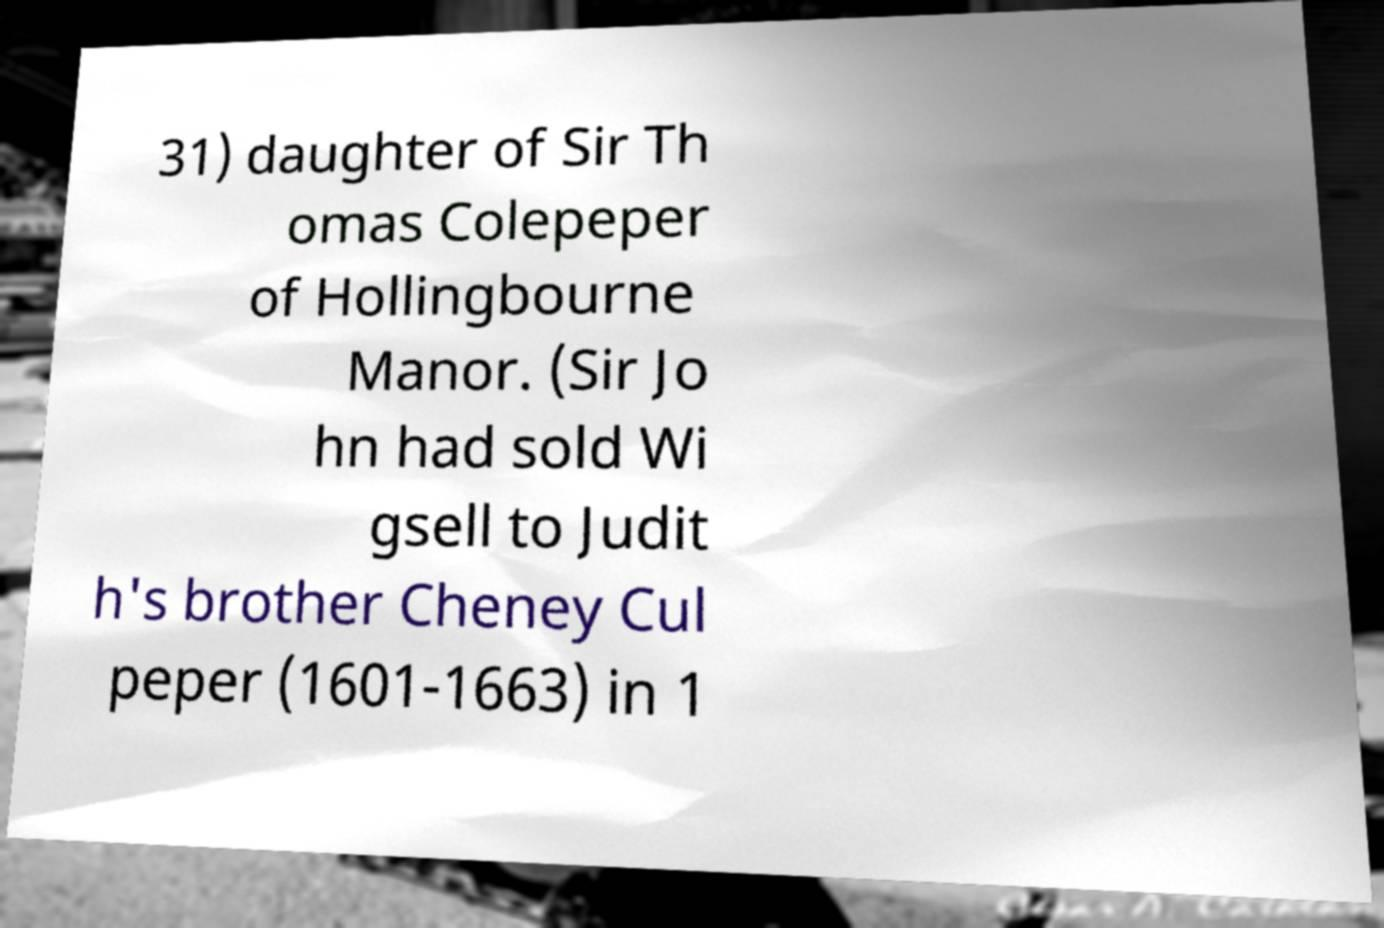I need the written content from this picture converted into text. Can you do that? 31) daughter of Sir Th omas Colepeper of Hollingbourne Manor. (Sir Jo hn had sold Wi gsell to Judit h's brother Cheney Cul peper (1601-1663) in 1 